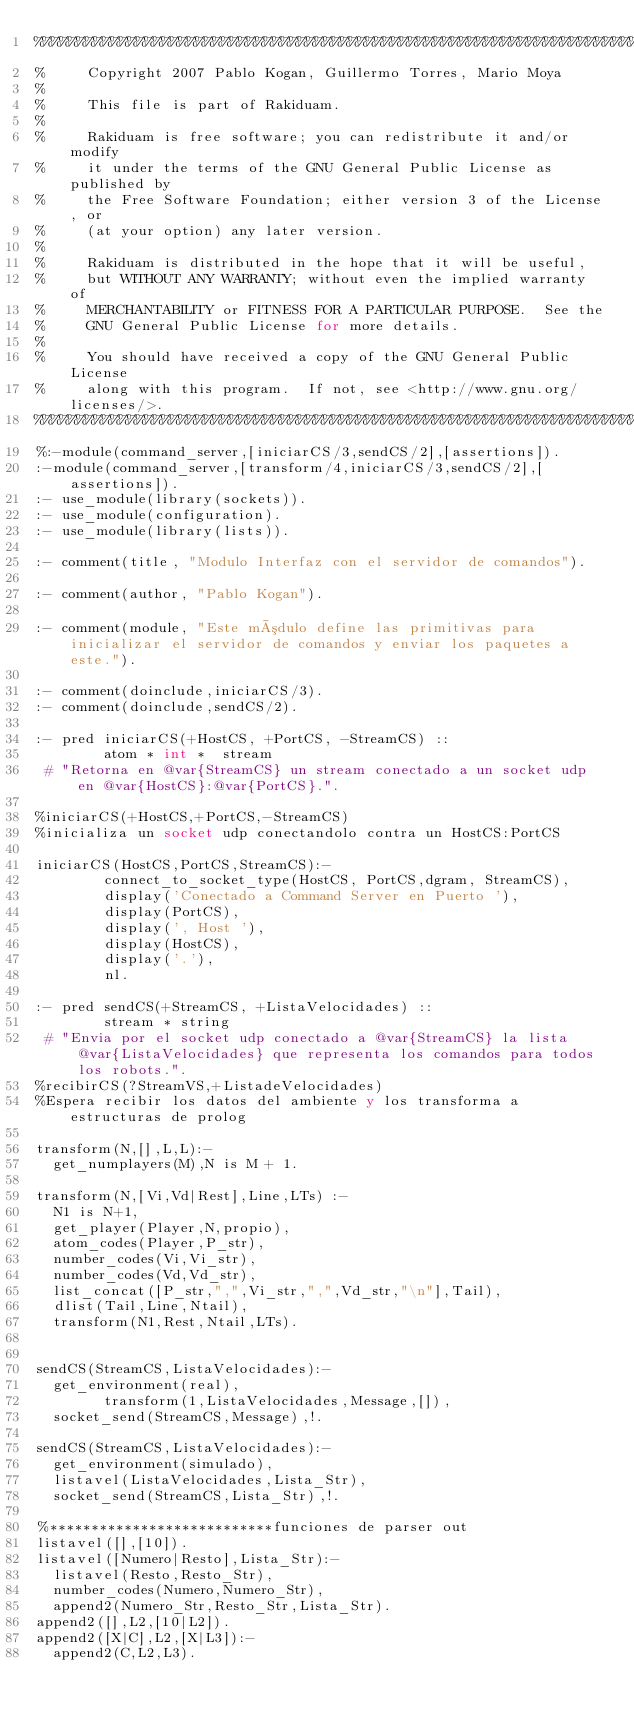<code> <loc_0><loc_0><loc_500><loc_500><_Perl_>%%%%%%%%%%%%%%%%%%%%%%%%%%%%%%%%%%%%%%%%%%%%%%%%%%%%%%%%%%%%%%%%%%%%%%%%%%%
%     Copyright 2007 Pablo Kogan, Guillermo Torres, Mario Moya
%
%     This file is part of Rakiduam.
%
%     Rakiduam is free software; you can redistribute it and/or modify
%     it under the terms of the GNU General Public License as published by
%     the Free Software Foundation; either version 3 of the License, or
%     (at your option) any later version.
%
%     Rakiduam is distributed in the hope that it will be useful,
%     but WITHOUT ANY WARRANTY; without even the implied warranty of
%     MERCHANTABILITY or FITNESS FOR A PARTICULAR PURPOSE.  See the
%     GNU General Public License for more details.
%
%     You should have received a copy of the GNU General Public License
%     along with this program.  If not, see <http://www.gnu.org/licenses/>.
%%%%%%%%%%%%%%%%%%%%%%%%%%%%%%%%%%%%%%%%%%%%%%%%%%%%%%%%%%%%%%%%%%%%%%%%%%%
%:-module(command_server,[iniciarCS/3,sendCS/2],[assertions]).
:-module(command_server,[transform/4,iniciarCS/3,sendCS/2],[assertions]).
:- use_module(library(sockets)).
:- use_module(configuration).
:- use_module(library(lists)).

:- comment(title, "Modulo Interfaz con el servidor de comandos").

:- comment(author, "Pablo Kogan").

:- comment(module, "Este módulo define las primitivas para inicializar el servidor de comandos y enviar los paquetes a este.").

:- comment(doinclude,iniciarCS/3).
:- comment(doinclude,sendCS/2).

:- pred iniciarCS(+HostCS, +PortCS, -StreamCS) ::
        atom * int *  stream
 # "Retorna en @var{StreamCS} un stream conectado a un socket udp en @var{HostCS}:@var{PortCS}.".

%iniciarCS(+HostCS,+PortCS,-StreamCS)
%inicializa un socket udp conectandolo contra un HostCS:PortCS

iniciarCS(HostCS,PortCS,StreamCS):-
        connect_to_socket_type(HostCS, PortCS,dgram, StreamCS), 
        display('Conectado a Command Server en Puerto '),
        display(PortCS),
        display(', Host '),
        display(HostCS),
        display('.'),
        nl.

:- pred sendCS(+StreamCS, +ListaVelocidades) ::
        stream * string
 # "Envia por el socket udp conectado a @var{StreamCS} la lista @var{ListaVelocidades} que representa los comandos para todos los robots.".
%recibirCS(?StreamVS,+ListadeVelocidades)
%Espera recibir los datos del ambiente y los transforma a estructuras de prolog

transform(N,[],L,L):-
	get_numplayers(M),N is M + 1.

transform(N,[Vi,Vd|Rest],Line,LTs) :-
	N1 is N+1,
	get_player(Player,N,propio),
	atom_codes(Player,P_str),
	number_codes(Vi,Vi_str),
	number_codes(Vd,Vd_str),
	list_concat([P_str,",",Vi_str,",",Vd_str,"\n"],Tail),
	dlist(Tail,Line,Ntail),
	transform(N1,Rest,Ntail,LTs).
	

sendCS(StreamCS,ListaVelocidades):-
	get_environment(real),
        transform(1,ListaVelocidades,Message,[]),
 	socket_send(StreamCS,Message),!.

sendCS(StreamCS,ListaVelocidades):-
	get_environment(simulado),
	listavel(ListaVelocidades,Lista_Str),
 	socket_send(StreamCS,Lista_Str),!.

%***************************funciones de parser out
listavel([],[10]).
listavel([Numero|Resto],Lista_Str):-
	listavel(Resto,Resto_Str),
	number_codes(Numero,Numero_Str),
	append2(Numero_Str,Resto_Str,Lista_Str).
append2([],L2,[10|L2]).
append2([X|C],L2,[X|L3]):-
	append2(C,L2,L3).

	
	
</code> 